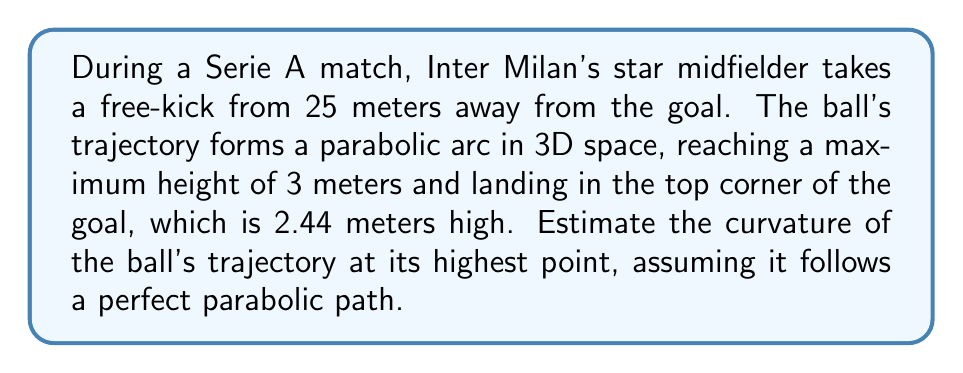Teach me how to tackle this problem. Let's approach this step-by-step:

1) In 3D space, the trajectory of the ball can be described by parametric equations:

   $$x(t) = at$$
   $$y(t) = bt$$
   $$z(t) = -ct^2 + dt$$

   where $z$ represents the vertical direction.

2) The curvature of a curve in 3D space is given by:

   $$\kappa = \frac{\sqrt{|\dot{\mathbf{r}} \times \ddot{\mathbf{r}}|^2}}{|\dot{\mathbf{r}}|^3}$$

   where $\dot{\mathbf{r}}$ and $\ddot{\mathbf{r}}$ are the first and second derivatives of the position vector.

3) At the highest point, $\dot{z} = 0$, so $t = \frac{d}{2c}$.

4) The derivatives at this point are:
   
   $$\dot{\mathbf{r}} = (a, b, 0)$$
   $$\ddot{\mathbf{r}} = (0, 0, -2c)$$

5) Calculating the cross product:

   $$\dot{\mathbf{r}} \times \ddot{\mathbf{r}} = (2bc, -2ac, 0)$$

6) The magnitude of this cross product is:

   $$|\dot{\mathbf{r}} \times \ddot{\mathbf{r}}| = 2c\sqrt{a^2 + b^2}$$

7) The magnitude of $\dot{\mathbf{r}}$ is:

   $$|\dot{\mathbf{r}}| = \sqrt{a^2 + b^2}$$

8) Substituting into the curvature formula:

   $$\kappa = \frac{2c\sqrt{a^2 + b^2}}{(a^2 + b^2)^{3/2}} = \frac{2c}{a^2 + b^2}$$

9) We don't know $a$, $b$, and $c$ exactly, but we can estimate. The horizontal distance is 25 meters, so $a^2 + b^2 \approx 25^2 = 625$.

10) For the parabola $z = -ct^2 + dt$, the maximum height is $\frac{d^2}{4c}$. Here, that's 3 meters. So:

    $$3 = \frac{d^2}{4c}$$

11) Also, at $t = 1$ (assuming the time of flight is 1 second), $z = 2.44$. So:

    $$2.44 = -c + d$$

12) Solving these equations:

    $$c \approx 0.56$$
    $$d \approx 3$$

13) Therefore, the estimated curvature is:

    $$\kappa \approx \frac{2(0.56)}{625} = 0.001792 \text{ m}^{-1}$$
Answer: $0.001792 \text{ m}^{-1}$ 